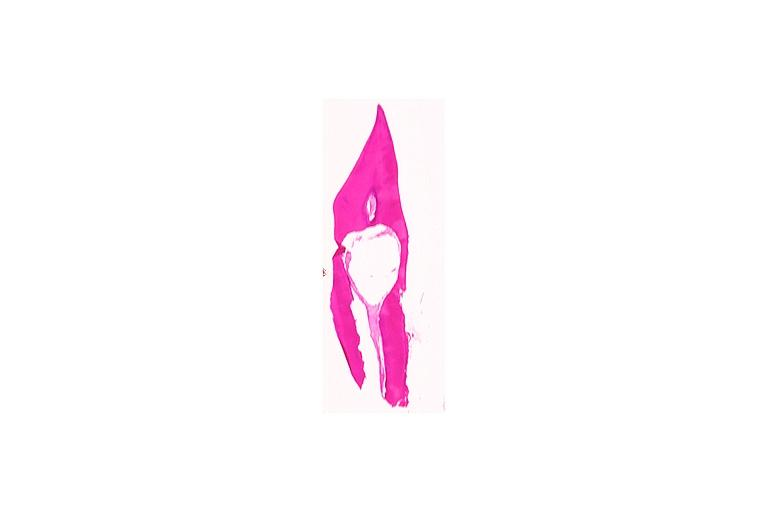s the excellent uterus present?
Answer the question using a single word or phrase. No 